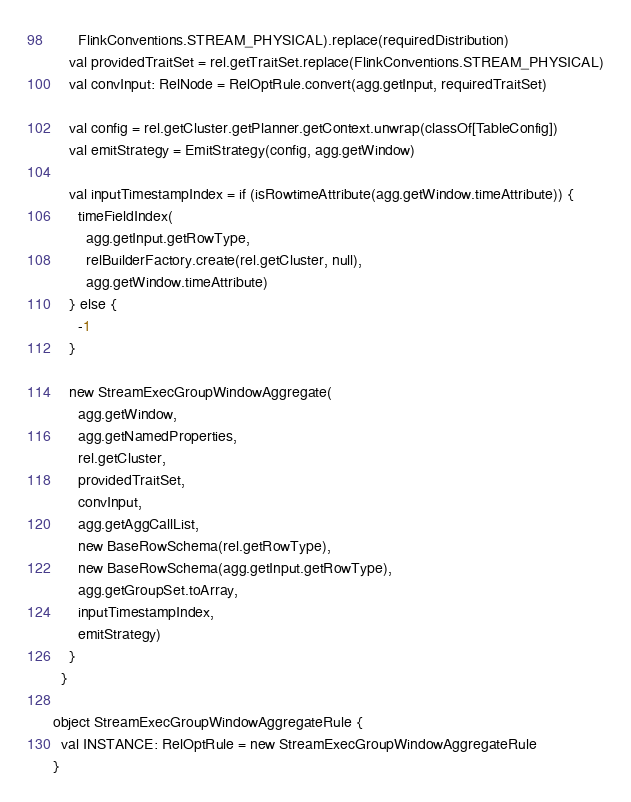<code> <loc_0><loc_0><loc_500><loc_500><_Scala_>      FlinkConventions.STREAM_PHYSICAL).replace(requiredDistribution)
    val providedTraitSet = rel.getTraitSet.replace(FlinkConventions.STREAM_PHYSICAL)
    val convInput: RelNode = RelOptRule.convert(agg.getInput, requiredTraitSet)

    val config = rel.getCluster.getPlanner.getContext.unwrap(classOf[TableConfig])
    val emitStrategy = EmitStrategy(config, agg.getWindow)

    val inputTimestampIndex = if (isRowtimeAttribute(agg.getWindow.timeAttribute)) {
      timeFieldIndex(
        agg.getInput.getRowType,
        relBuilderFactory.create(rel.getCluster, null),
        agg.getWindow.timeAttribute)
    } else {
      -1
    }

    new StreamExecGroupWindowAggregate(
      agg.getWindow,
      agg.getNamedProperties,
      rel.getCluster,
      providedTraitSet,
      convInput,
      agg.getAggCallList,
      new BaseRowSchema(rel.getRowType),
      new BaseRowSchema(agg.getInput.getRowType),
      agg.getGroupSet.toArray,
      inputTimestampIndex,
      emitStrategy)
    }
  }

object StreamExecGroupWindowAggregateRule {
  val INSTANCE: RelOptRule = new StreamExecGroupWindowAggregateRule
}
</code> 